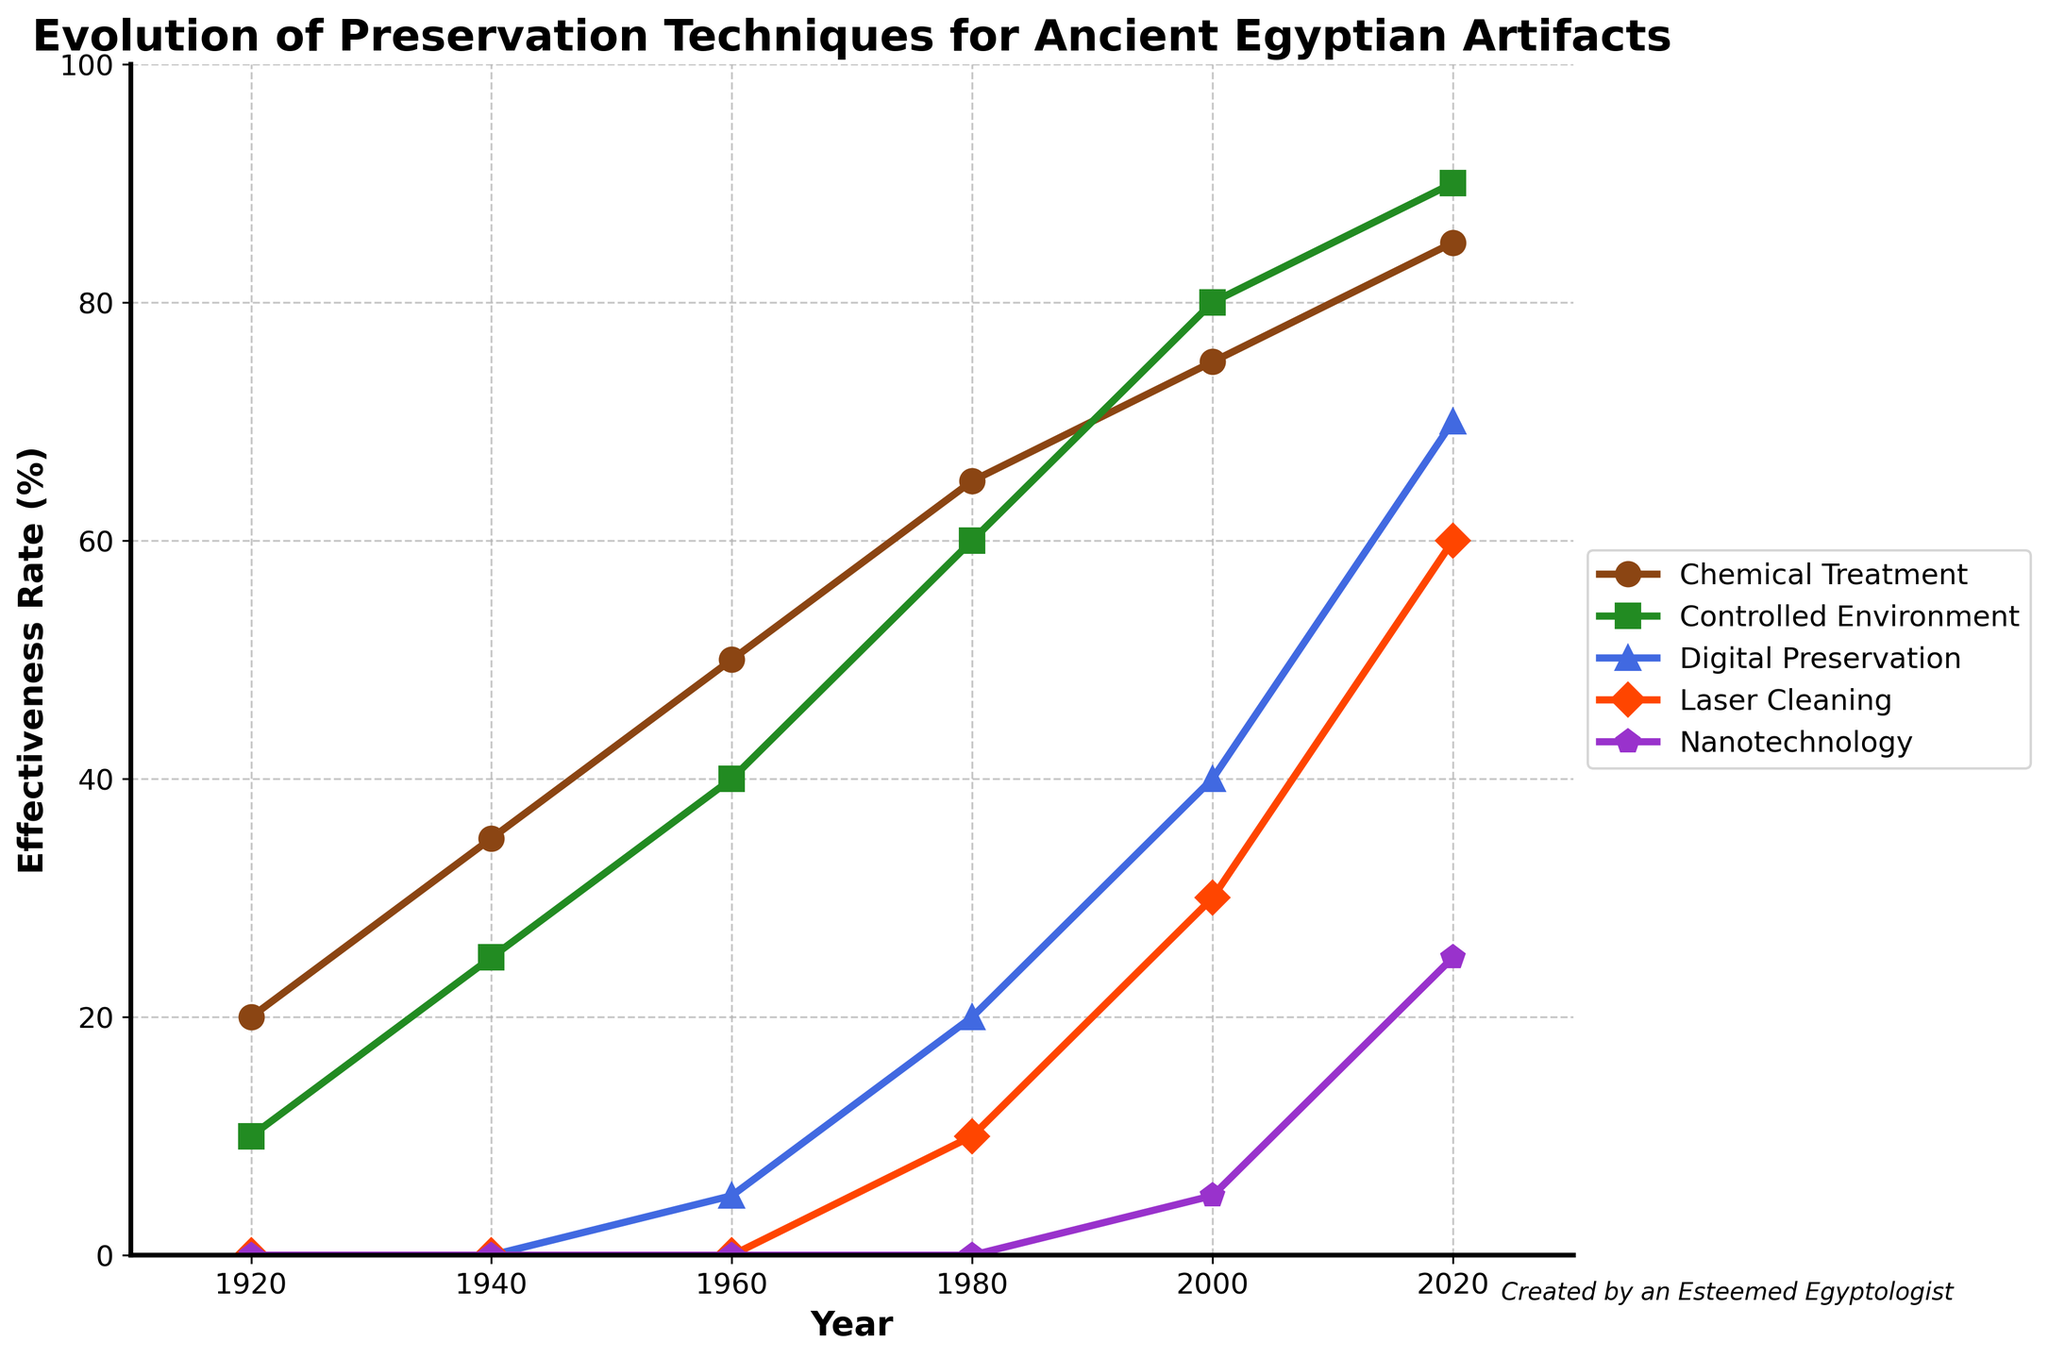What is the effectiveness rate of Chemical Treatment in the year 1940? The line for Chemical Treatment in 1940 shows a data point at approximately 35%.
Answer: 35% Which preservation technique has the highest effectiveness rate in 2020? By visually inspecting the lines at the year 2020, the Controlled Environment technique reaches the highest point at 90%.
Answer: Controlled Environment How did the effectiveness rate of Digital Preservation change from 1980 to 2000? In 1980, Digital Preservation was at 20%, and in 2000 it increased to 40%; the difference is 40% - 20% = 20%.
Answer: Increased by 20% Which technique saw the most significant increase in effectiveness rate between 2000 and 2020? Nanotechnology increased from 5% in 2000 to 25% in 2020, which is an increase of 20%, the highest among all techniques.
Answer: Nanotechnology What is the sum of effectiveness rates for Laser Cleaning and Nanotechnology in the year 2020? In 2020, Laser Cleaning is at 60%, and Nanotechnology is at 25%. Their sum is 60% + 25% = 85%.
Answer: 85% Which technique had a consistent increase in effectiveness rate across all recorded years? All techniques show an increasing trend, but Controlled Environment has the most consistent increase without any dips or plateaus from 10% in 1920 to 90% in 2020.
Answer: Controlled Environment What is the median effectiveness rate of Chemical Treatment from 1920 to 2020? The effectiveness rates for Chemical Treatment are [20, 35, 50, 65, 75, 85]. The median is the average of the two middle values: (50 + 65) / 2 = 57.5%.
Answer: 57.5% Which preservation technique had an effectiveness rate of 0% before 1960? Both Digital Preservation and Laser Cleaning had 0% effectiveness rates before 1960.
Answer: Digital Preservation, Laser Cleaning Between 1920 and 1960, which technique saw the greatest relative increase in effectiveness? Chemical Treatment increased from 20% in 1920 to 50% in 1960, which is an increase of 30%. Controlled Environment increased from 10% to 40%, an increase of 30%, which is relative increase of 3x, compared to Chemical Treatment's relative increase of 2.5x.
Answer: Controlled Environment Which preservation technique had the least growth in effectiveness rate from 2000 to 2020? Controlled Environment increased from 80% to 90% (10 units), while Chemical Treatment increased from 75% to 85% (10 units), others had larger changes. Therefore, in these terms, Chemical Treatment had the least growth.
Answer: Chemical Treatment 